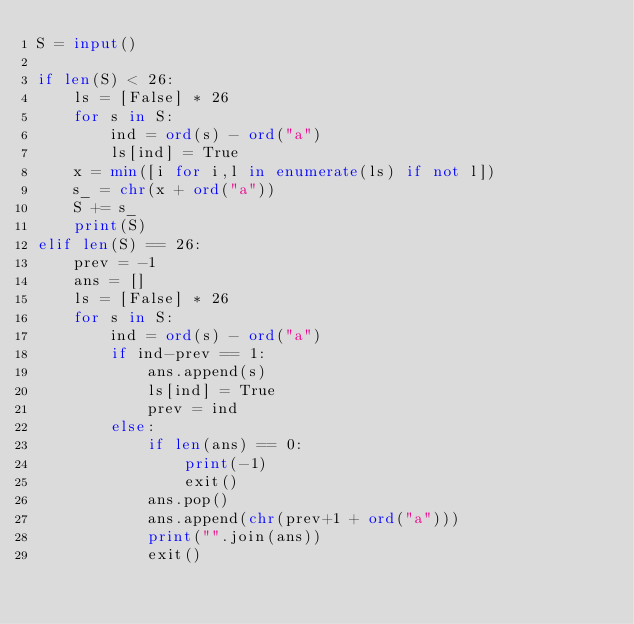Convert code to text. <code><loc_0><loc_0><loc_500><loc_500><_Python_>S = input()

if len(S) < 26:
    ls = [False] * 26
    for s in S:
        ind = ord(s) - ord("a")
        ls[ind] = True
    x = min([i for i,l in enumerate(ls) if not l])
    s_ = chr(x + ord("a"))
    S += s_
    print(S)
elif len(S) == 26:
    prev = -1
    ans = []
    ls = [False] * 26
    for s in S:
        ind = ord(s) - ord("a")
        if ind-prev == 1:
            ans.append(s)
            ls[ind] = True
            prev = ind
        else:
            if len(ans) == 0:
                print(-1)
                exit()
            ans.pop()
            ans.append(chr(prev+1 + ord("a")))
            print("".join(ans))
            exit()
</code> 